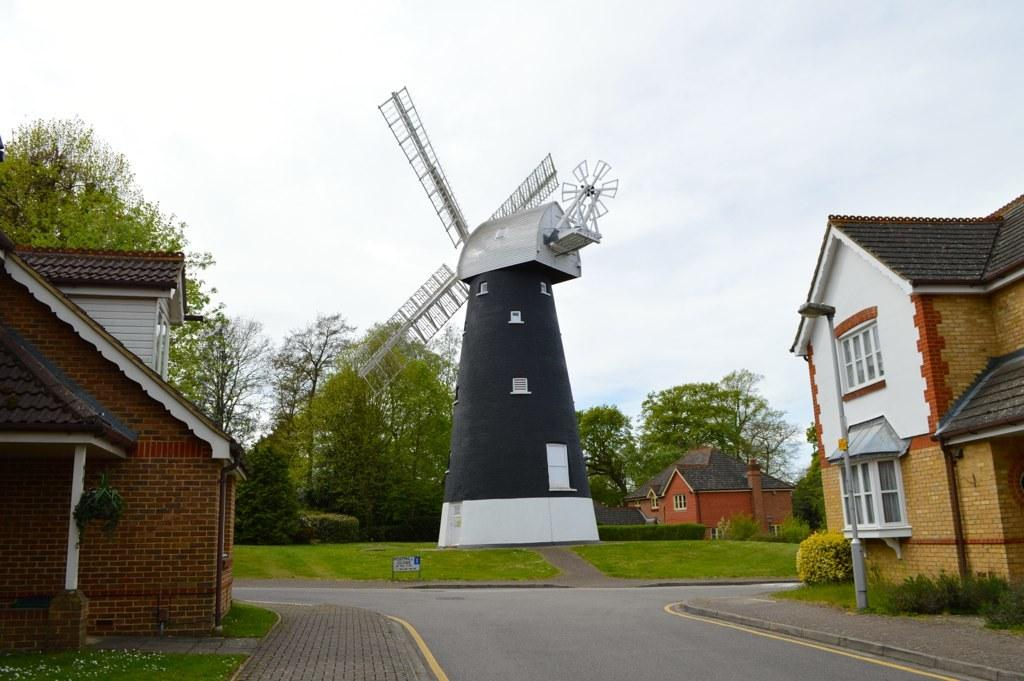What type of structures can be seen in the image? There are houses in the image. Can you describe a specific house in the image? There is a house with a fan in the image. What type of vegetation is present in the image? There are trees and plants in the image. How does the tent compare to the houses in the image? There is no tent present in the image, so it cannot be compared to the houses. 